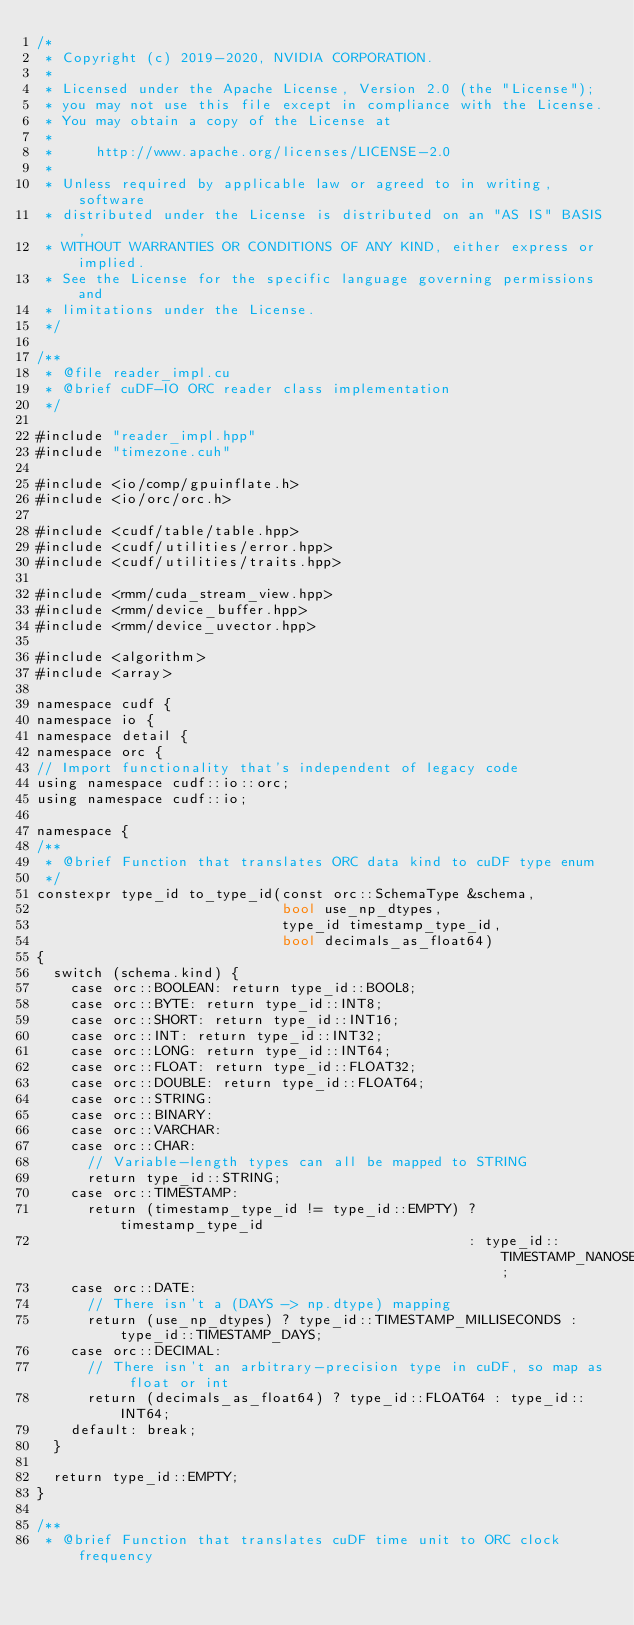<code> <loc_0><loc_0><loc_500><loc_500><_Cuda_>/*
 * Copyright (c) 2019-2020, NVIDIA CORPORATION.
 *
 * Licensed under the Apache License, Version 2.0 (the "License");
 * you may not use this file except in compliance with the License.
 * You may obtain a copy of the License at
 *
 *     http://www.apache.org/licenses/LICENSE-2.0
 *
 * Unless required by applicable law or agreed to in writing, software
 * distributed under the License is distributed on an "AS IS" BASIS,
 * WITHOUT WARRANTIES OR CONDITIONS OF ANY KIND, either express or implied.
 * See the License for the specific language governing permissions and
 * limitations under the License.
 */

/**
 * @file reader_impl.cu
 * @brief cuDF-IO ORC reader class implementation
 */

#include "reader_impl.hpp"
#include "timezone.cuh"

#include <io/comp/gpuinflate.h>
#include <io/orc/orc.h>

#include <cudf/table/table.hpp>
#include <cudf/utilities/error.hpp>
#include <cudf/utilities/traits.hpp>

#include <rmm/cuda_stream_view.hpp>
#include <rmm/device_buffer.hpp>
#include <rmm/device_uvector.hpp>

#include <algorithm>
#include <array>

namespace cudf {
namespace io {
namespace detail {
namespace orc {
// Import functionality that's independent of legacy code
using namespace cudf::io::orc;
using namespace cudf::io;

namespace {
/**
 * @brief Function that translates ORC data kind to cuDF type enum
 */
constexpr type_id to_type_id(const orc::SchemaType &schema,
                             bool use_np_dtypes,
                             type_id timestamp_type_id,
                             bool decimals_as_float64)
{
  switch (schema.kind) {
    case orc::BOOLEAN: return type_id::BOOL8;
    case orc::BYTE: return type_id::INT8;
    case orc::SHORT: return type_id::INT16;
    case orc::INT: return type_id::INT32;
    case orc::LONG: return type_id::INT64;
    case orc::FLOAT: return type_id::FLOAT32;
    case orc::DOUBLE: return type_id::FLOAT64;
    case orc::STRING:
    case orc::BINARY:
    case orc::VARCHAR:
    case orc::CHAR:
      // Variable-length types can all be mapped to STRING
      return type_id::STRING;
    case orc::TIMESTAMP:
      return (timestamp_type_id != type_id::EMPTY) ? timestamp_type_id
                                                   : type_id::TIMESTAMP_NANOSECONDS;
    case orc::DATE:
      // There isn't a (DAYS -> np.dtype) mapping
      return (use_np_dtypes) ? type_id::TIMESTAMP_MILLISECONDS : type_id::TIMESTAMP_DAYS;
    case orc::DECIMAL:
      // There isn't an arbitrary-precision type in cuDF, so map as float or int
      return (decimals_as_float64) ? type_id::FLOAT64 : type_id::INT64;
    default: break;
  }

  return type_id::EMPTY;
}

/**
 * @brief Function that translates cuDF time unit to ORC clock frequency</code> 